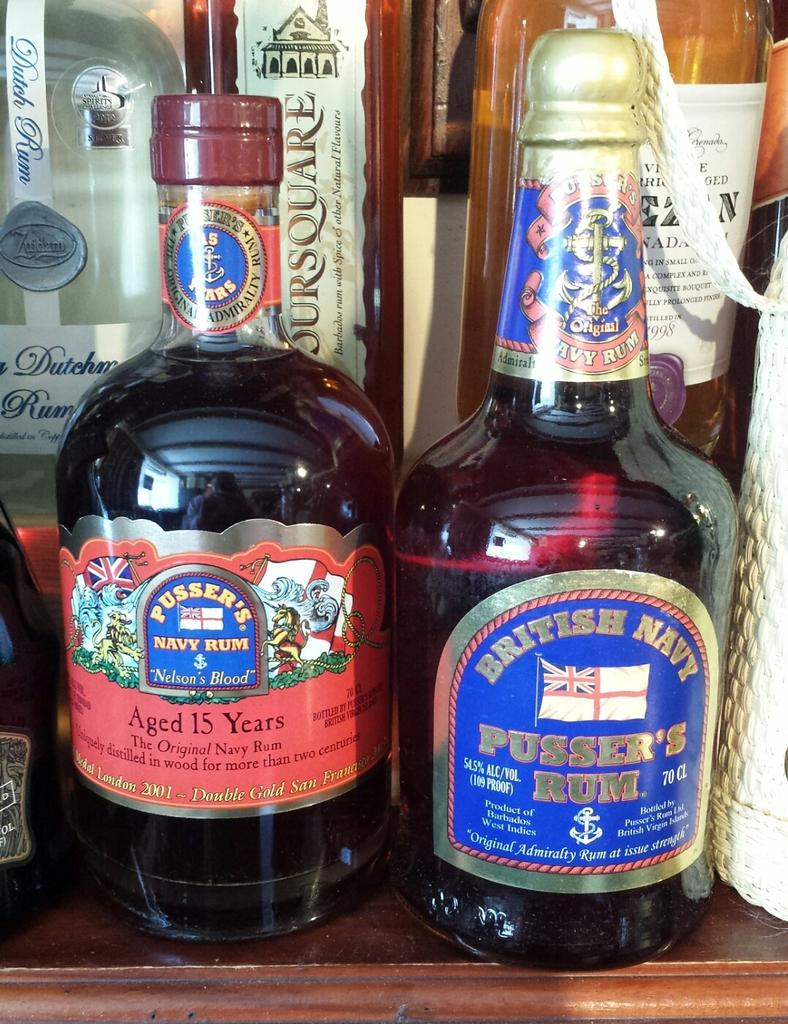<image>
Give a short and clear explanation of the subsequent image. two bottles of alchohol, pusser's navy rum and british navy pusser's rum 